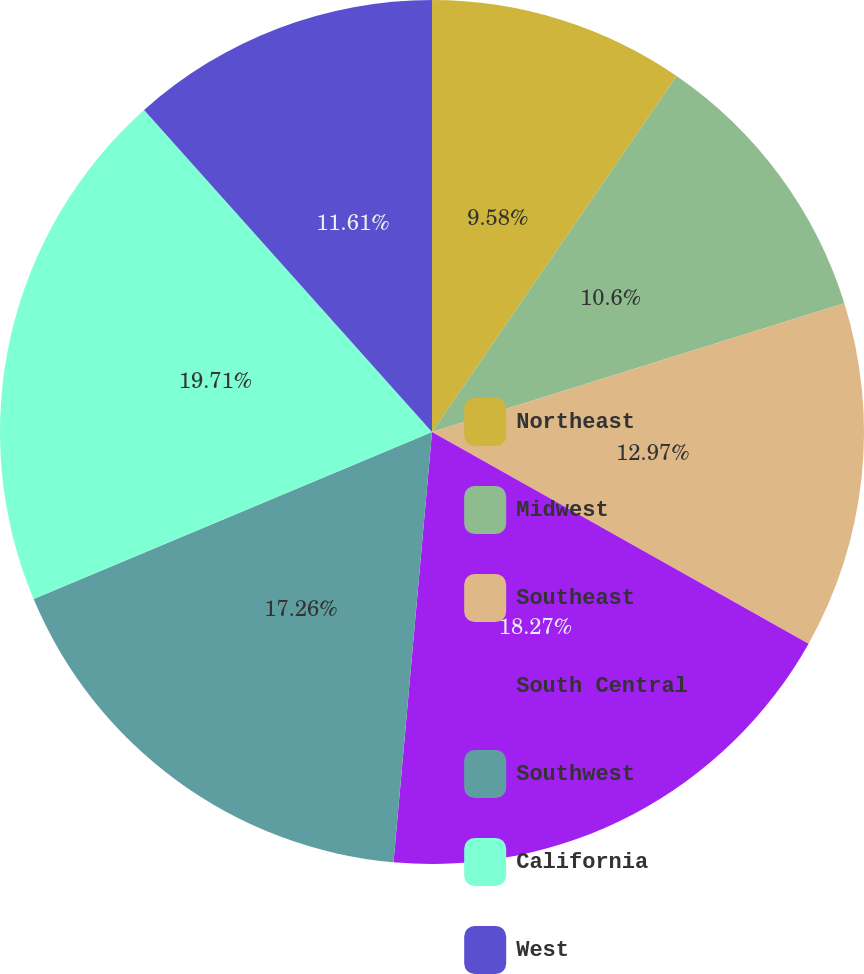<chart> <loc_0><loc_0><loc_500><loc_500><pie_chart><fcel>Northeast<fcel>Midwest<fcel>Southeast<fcel>South Central<fcel>Southwest<fcel>California<fcel>West<nl><fcel>9.58%<fcel>10.6%<fcel>12.97%<fcel>18.27%<fcel>17.26%<fcel>19.71%<fcel>11.61%<nl></chart> 